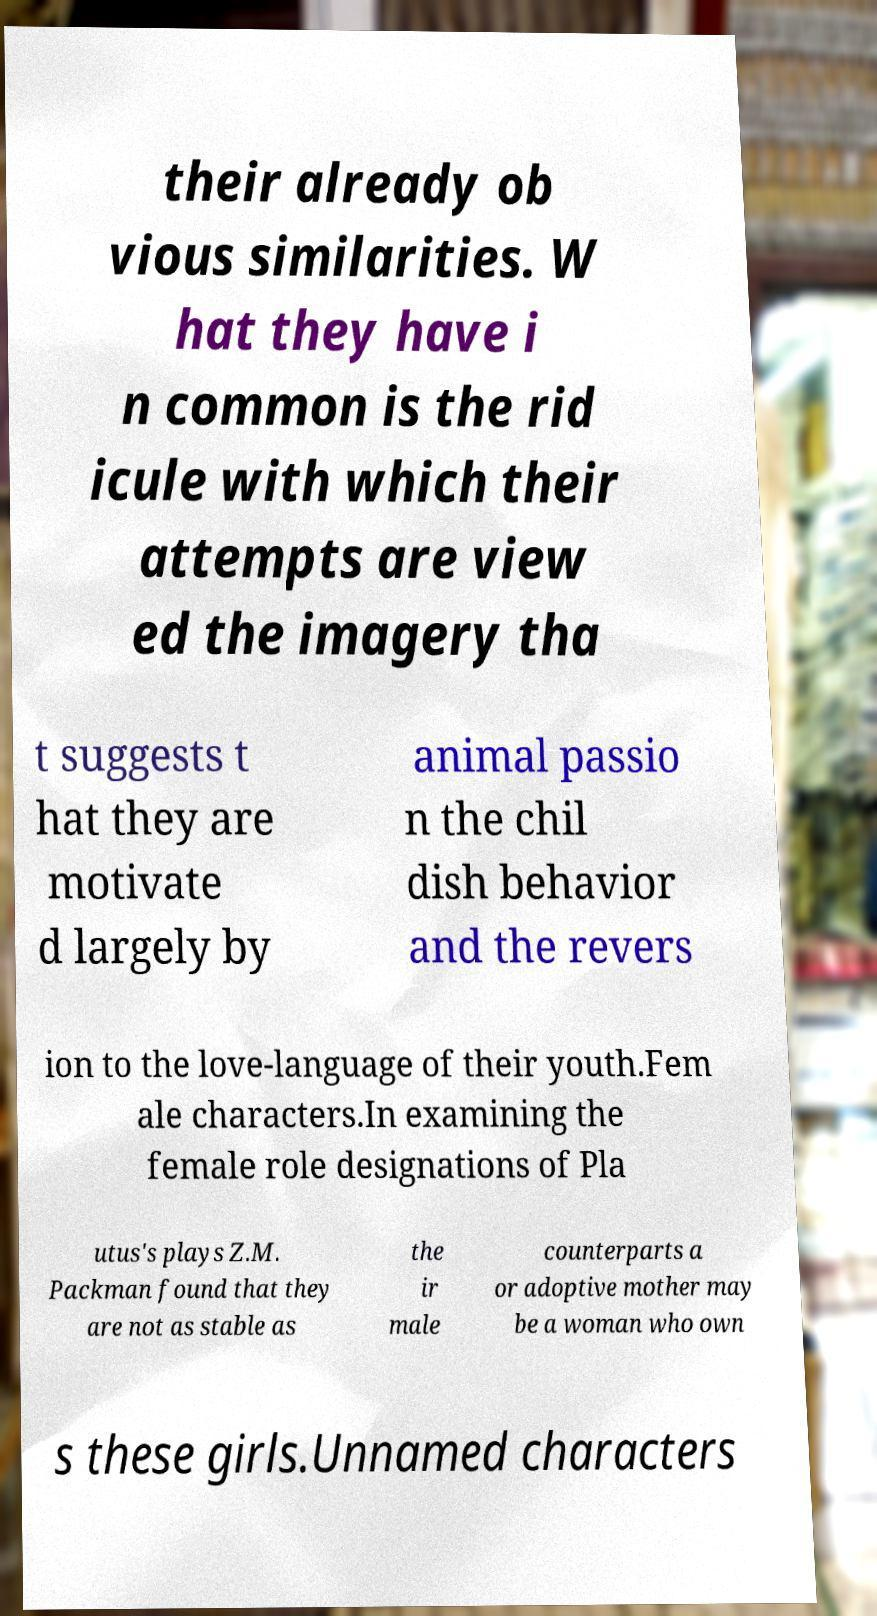Could you extract and type out the text from this image? their already ob vious similarities. W hat they have i n common is the rid icule with which their attempts are view ed the imagery tha t suggests t hat they are motivate d largely by animal passio n the chil dish behavior and the revers ion to the love-language of their youth.Fem ale characters.In examining the female role designations of Pla utus's plays Z.M. Packman found that they are not as stable as the ir male counterparts a or adoptive mother may be a woman who own s these girls.Unnamed characters 